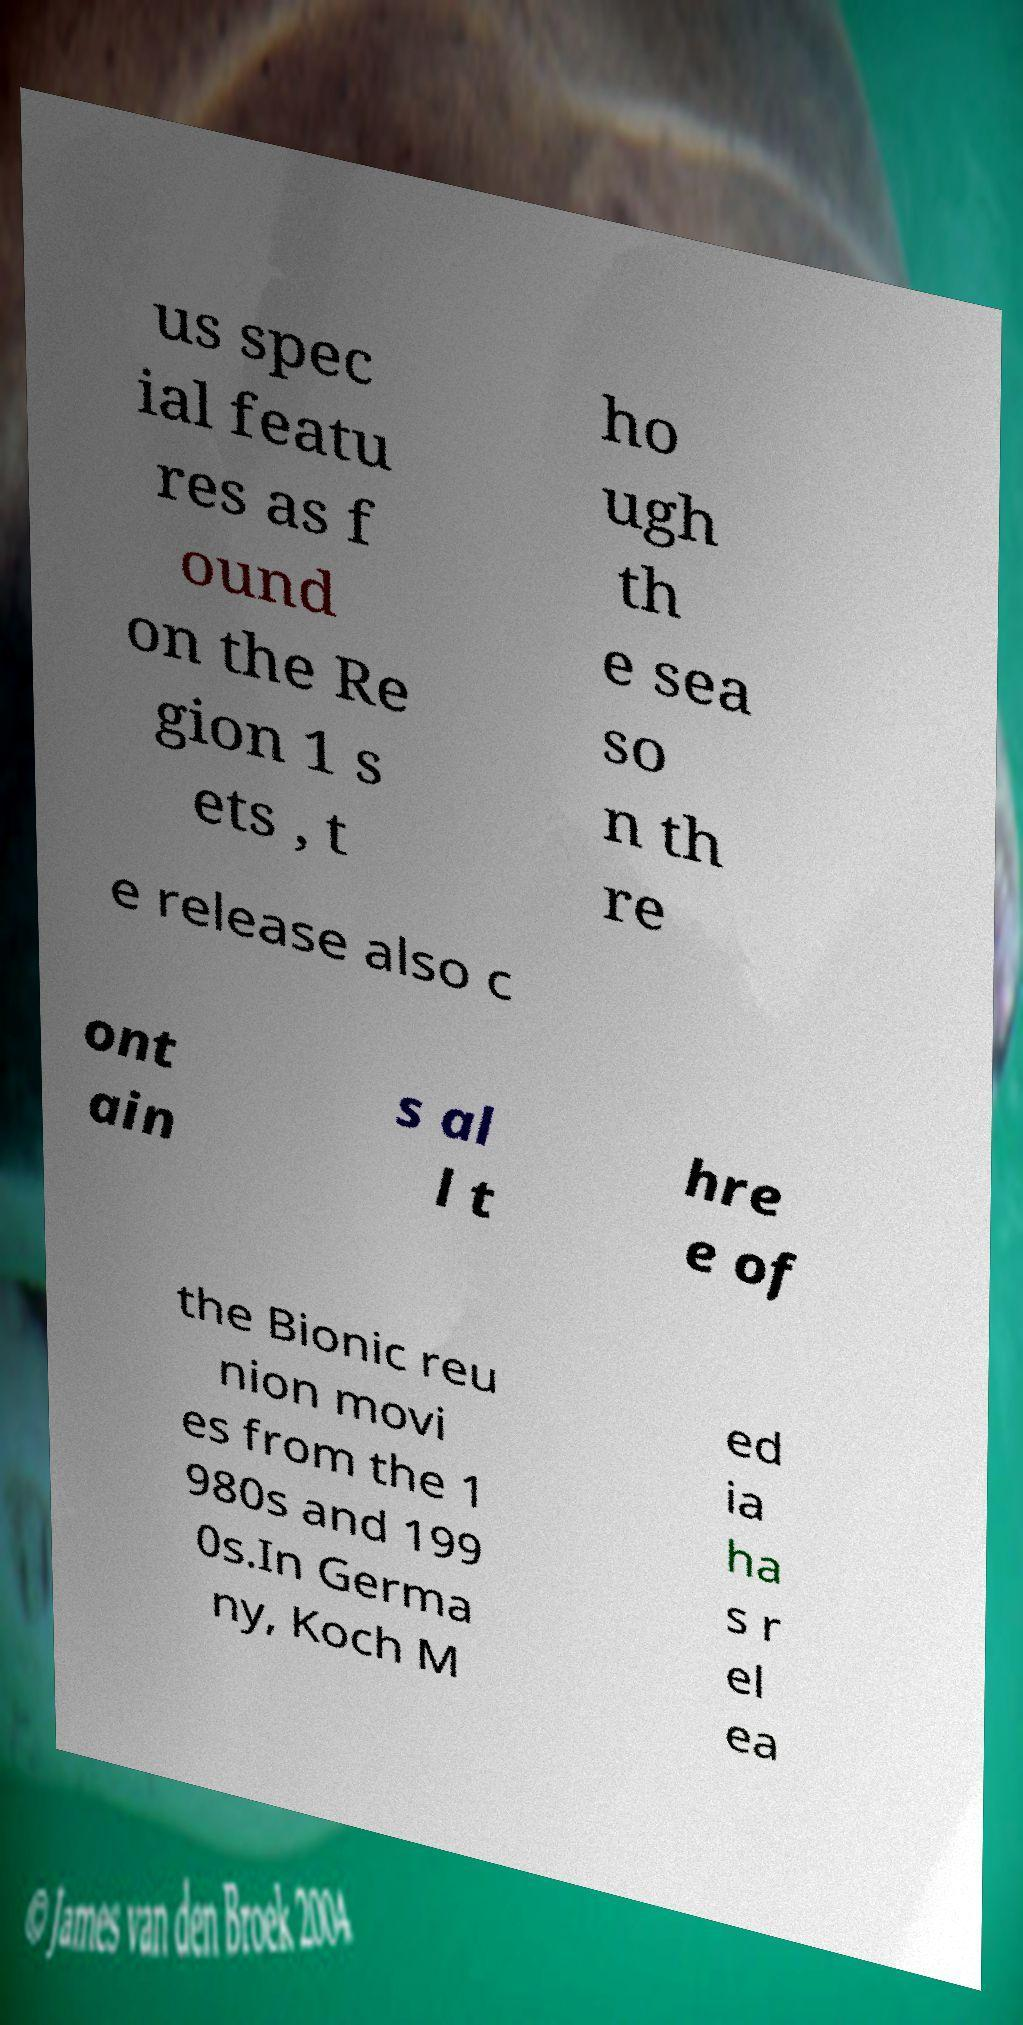Can you read and provide the text displayed in the image?This photo seems to have some interesting text. Can you extract and type it out for me? us spec ial featu res as f ound on the Re gion 1 s ets , t ho ugh th e sea so n th re e release also c ont ain s al l t hre e of the Bionic reu nion movi es from the 1 980s and 199 0s.In Germa ny, Koch M ed ia ha s r el ea 